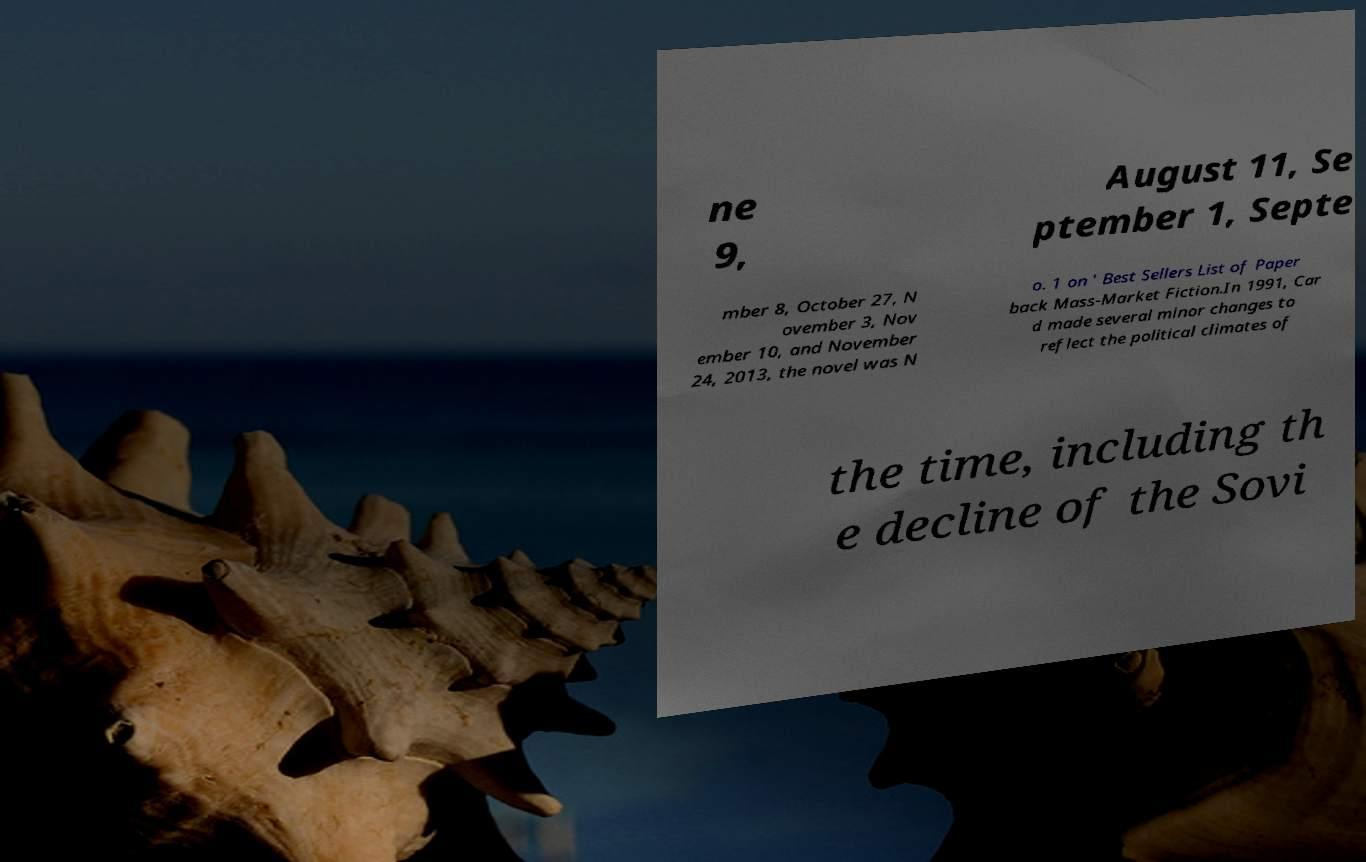Please identify and transcribe the text found in this image. ne 9, August 11, Se ptember 1, Septe mber 8, October 27, N ovember 3, Nov ember 10, and November 24, 2013, the novel was N o. 1 on ' Best Sellers List of Paper back Mass-Market Fiction.In 1991, Car d made several minor changes to reflect the political climates of the time, including th e decline of the Sovi 